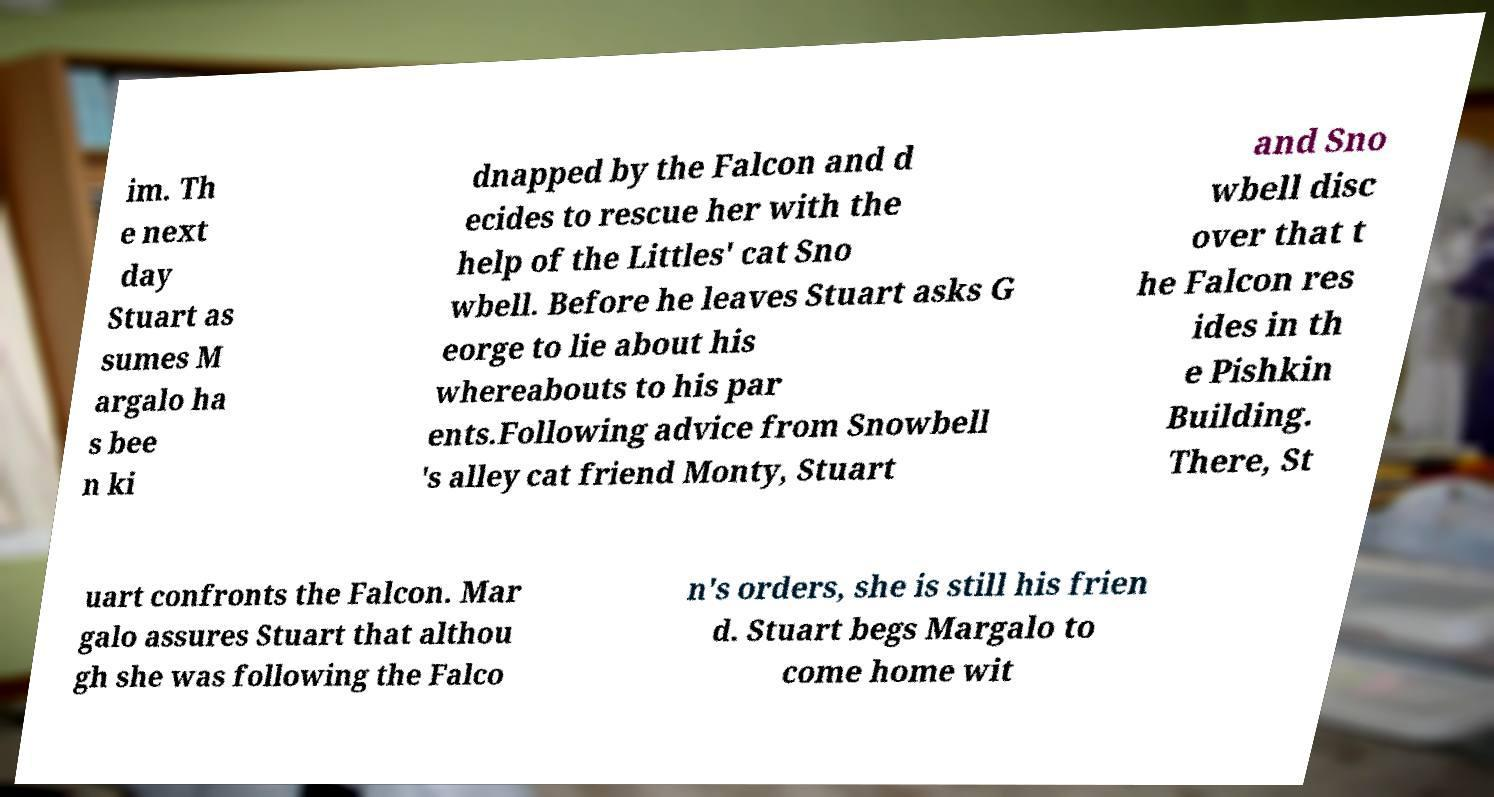Can you accurately transcribe the text from the provided image for me? im. Th e next day Stuart as sumes M argalo ha s bee n ki dnapped by the Falcon and d ecides to rescue her with the help of the Littles' cat Sno wbell. Before he leaves Stuart asks G eorge to lie about his whereabouts to his par ents.Following advice from Snowbell 's alley cat friend Monty, Stuart and Sno wbell disc over that t he Falcon res ides in th e Pishkin Building. There, St uart confronts the Falcon. Mar galo assures Stuart that althou gh she was following the Falco n's orders, she is still his frien d. Stuart begs Margalo to come home wit 